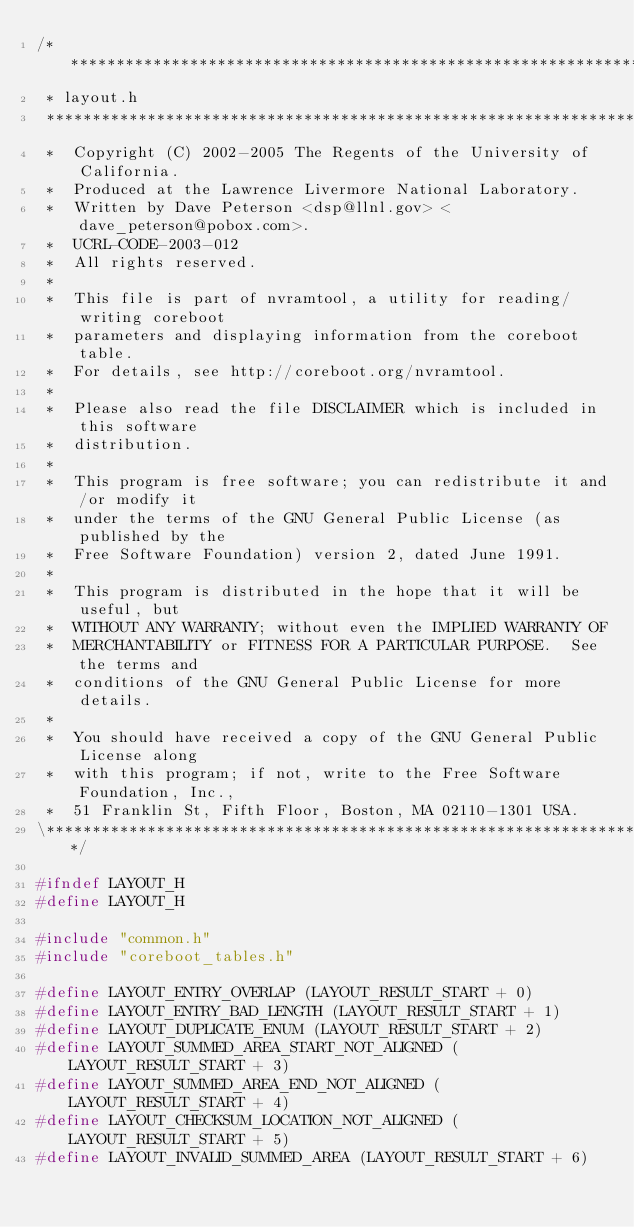Convert code to text. <code><loc_0><loc_0><loc_500><loc_500><_C_>/*****************************************************************************\
 * layout.h
 *****************************************************************************
 *  Copyright (C) 2002-2005 The Regents of the University of California.
 *  Produced at the Lawrence Livermore National Laboratory.
 *  Written by Dave Peterson <dsp@llnl.gov> <dave_peterson@pobox.com>.
 *  UCRL-CODE-2003-012
 *  All rights reserved.
 *
 *  This file is part of nvramtool, a utility for reading/writing coreboot
 *  parameters and displaying information from the coreboot table.
 *  For details, see http://coreboot.org/nvramtool.
 *
 *  Please also read the file DISCLAIMER which is included in this software
 *  distribution.
 *
 *  This program is free software; you can redistribute it and/or modify it
 *  under the terms of the GNU General Public License (as published by the
 *  Free Software Foundation) version 2, dated June 1991.
 *
 *  This program is distributed in the hope that it will be useful, but
 *  WITHOUT ANY WARRANTY; without even the IMPLIED WARRANTY OF
 *  MERCHANTABILITY or FITNESS FOR A PARTICULAR PURPOSE.  See the terms and
 *  conditions of the GNU General Public License for more details.
 *
 *  You should have received a copy of the GNU General Public License along
 *  with this program; if not, write to the Free Software Foundation, Inc.,
 *  51 Franklin St, Fifth Floor, Boston, MA 02110-1301 USA.
\*****************************************************************************/

#ifndef LAYOUT_H
#define LAYOUT_H

#include "common.h"
#include "coreboot_tables.h"

#define LAYOUT_ENTRY_OVERLAP (LAYOUT_RESULT_START + 0)
#define LAYOUT_ENTRY_BAD_LENGTH (LAYOUT_RESULT_START + 1)
#define LAYOUT_DUPLICATE_ENUM (LAYOUT_RESULT_START + 2)
#define LAYOUT_SUMMED_AREA_START_NOT_ALIGNED (LAYOUT_RESULT_START + 3)
#define LAYOUT_SUMMED_AREA_END_NOT_ALIGNED (LAYOUT_RESULT_START + 4)
#define LAYOUT_CHECKSUM_LOCATION_NOT_ALIGNED (LAYOUT_RESULT_START + 5)
#define LAYOUT_INVALID_SUMMED_AREA (LAYOUT_RESULT_START + 6)</code> 